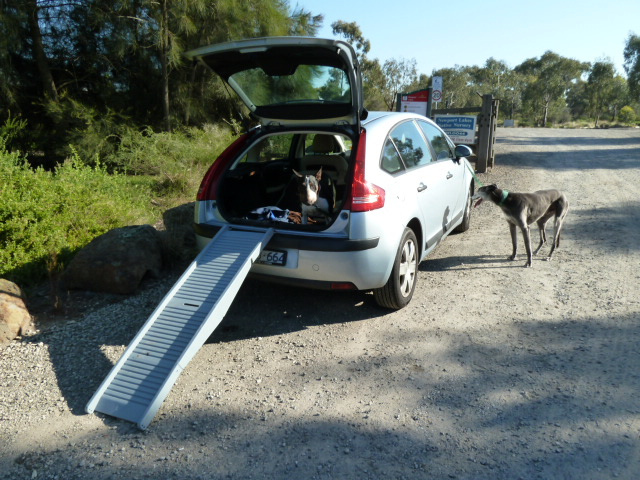Imagine the journey the dogs are about to go on. Where might they be going and why? The dogs might be headed to a nearby park or nature reserve for a fun day of running and playing. Alternatively, they could be on a road trip with their owners, exploring new trails and enjoying the fresh air together. The excitement in their eyes suggests they are eagerly anticipating a new adventure.  Describe a detailed narrative where these two dogs encounter unexpected adventures on their trip. As the car drives off, the two dogs, Max and Bella, eagerly look out the windows at the passing scenery. Their destination is a beautiful lake nestled in the mountains, known for its scenic trails and clear water. Upon arrival, they burst out of the car and run toward the trail. As they explore, they find a hidden path leading to a secret meadow. In the meadow, they encounter a family of deer. Max and Bella, ever curious and friendly, approach the deer carefully. They all end up playing together, forming an unlikely friendship. As the sun begins to set, Max and Bella return to their owners, tired but happy, with memories of an extraordinary day that will stay with them forever. 